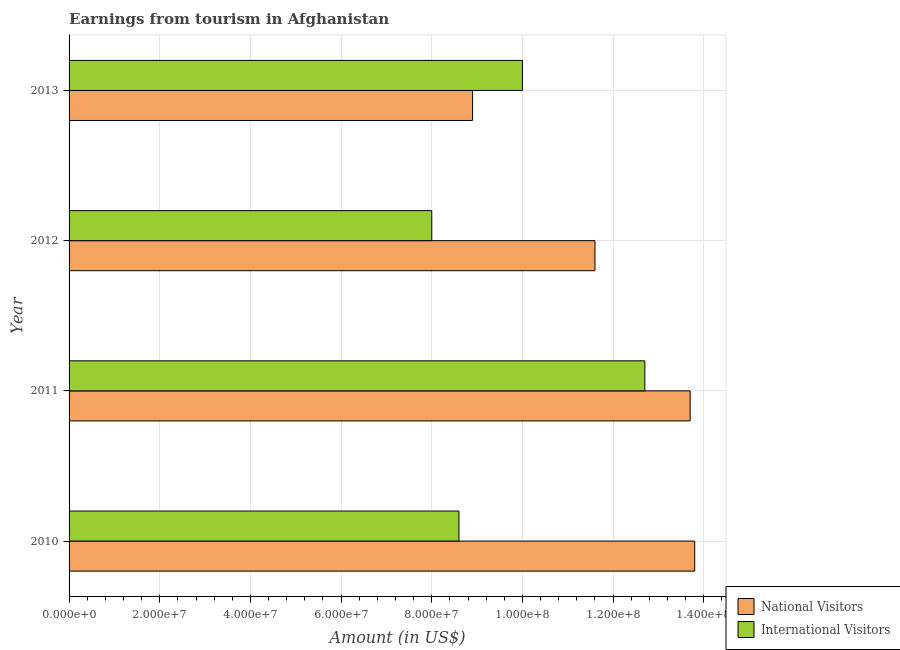How many groups of bars are there?
Your answer should be very brief. 4. Are the number of bars per tick equal to the number of legend labels?
Ensure brevity in your answer.  Yes. How many bars are there on the 1st tick from the bottom?
Provide a short and direct response. 2. What is the label of the 3rd group of bars from the top?
Provide a short and direct response. 2011. In how many cases, is the number of bars for a given year not equal to the number of legend labels?
Offer a terse response. 0. What is the amount earned from national visitors in 2013?
Give a very brief answer. 8.90e+07. Across all years, what is the maximum amount earned from national visitors?
Offer a very short reply. 1.38e+08. Across all years, what is the minimum amount earned from national visitors?
Offer a terse response. 8.90e+07. What is the total amount earned from national visitors in the graph?
Provide a short and direct response. 4.80e+08. What is the difference between the amount earned from national visitors in 2010 and that in 2011?
Make the answer very short. 1.00e+06. What is the difference between the amount earned from national visitors in 2011 and the amount earned from international visitors in 2012?
Offer a very short reply. 5.70e+07. What is the average amount earned from international visitors per year?
Your answer should be compact. 9.82e+07. In the year 2013, what is the difference between the amount earned from international visitors and amount earned from national visitors?
Provide a short and direct response. 1.10e+07. In how many years, is the amount earned from international visitors greater than 104000000 US$?
Provide a succinct answer. 1. What is the ratio of the amount earned from international visitors in 2011 to that in 2013?
Offer a terse response. 1.27. Is the amount earned from national visitors in 2010 less than that in 2012?
Give a very brief answer. No. Is the difference between the amount earned from national visitors in 2011 and 2012 greater than the difference between the amount earned from international visitors in 2011 and 2012?
Your response must be concise. No. What is the difference between the highest and the lowest amount earned from international visitors?
Your answer should be compact. 4.70e+07. In how many years, is the amount earned from national visitors greater than the average amount earned from national visitors taken over all years?
Offer a terse response. 2. What does the 2nd bar from the top in 2013 represents?
Provide a succinct answer. National Visitors. What does the 1st bar from the bottom in 2010 represents?
Provide a succinct answer. National Visitors. How many bars are there?
Provide a short and direct response. 8. How many years are there in the graph?
Make the answer very short. 4. Where does the legend appear in the graph?
Offer a very short reply. Bottom right. How are the legend labels stacked?
Your answer should be very brief. Vertical. What is the title of the graph?
Offer a very short reply. Earnings from tourism in Afghanistan. Does "Private credit bureau" appear as one of the legend labels in the graph?
Ensure brevity in your answer.  No. What is the Amount (in US$) of National Visitors in 2010?
Provide a short and direct response. 1.38e+08. What is the Amount (in US$) of International Visitors in 2010?
Your answer should be compact. 8.60e+07. What is the Amount (in US$) of National Visitors in 2011?
Give a very brief answer. 1.37e+08. What is the Amount (in US$) of International Visitors in 2011?
Ensure brevity in your answer.  1.27e+08. What is the Amount (in US$) in National Visitors in 2012?
Offer a terse response. 1.16e+08. What is the Amount (in US$) in International Visitors in 2012?
Make the answer very short. 8.00e+07. What is the Amount (in US$) in National Visitors in 2013?
Provide a short and direct response. 8.90e+07. Across all years, what is the maximum Amount (in US$) of National Visitors?
Offer a terse response. 1.38e+08. Across all years, what is the maximum Amount (in US$) of International Visitors?
Give a very brief answer. 1.27e+08. Across all years, what is the minimum Amount (in US$) of National Visitors?
Provide a succinct answer. 8.90e+07. Across all years, what is the minimum Amount (in US$) in International Visitors?
Provide a succinct answer. 8.00e+07. What is the total Amount (in US$) in National Visitors in the graph?
Make the answer very short. 4.80e+08. What is the total Amount (in US$) in International Visitors in the graph?
Offer a terse response. 3.93e+08. What is the difference between the Amount (in US$) in National Visitors in 2010 and that in 2011?
Provide a succinct answer. 1.00e+06. What is the difference between the Amount (in US$) of International Visitors in 2010 and that in 2011?
Your answer should be compact. -4.10e+07. What is the difference between the Amount (in US$) of National Visitors in 2010 and that in 2012?
Provide a short and direct response. 2.20e+07. What is the difference between the Amount (in US$) of International Visitors in 2010 and that in 2012?
Make the answer very short. 6.00e+06. What is the difference between the Amount (in US$) of National Visitors in 2010 and that in 2013?
Your response must be concise. 4.90e+07. What is the difference between the Amount (in US$) in International Visitors in 2010 and that in 2013?
Give a very brief answer. -1.40e+07. What is the difference between the Amount (in US$) in National Visitors in 2011 and that in 2012?
Provide a succinct answer. 2.10e+07. What is the difference between the Amount (in US$) in International Visitors in 2011 and that in 2012?
Offer a terse response. 4.70e+07. What is the difference between the Amount (in US$) in National Visitors in 2011 and that in 2013?
Offer a terse response. 4.80e+07. What is the difference between the Amount (in US$) of International Visitors in 2011 and that in 2013?
Your answer should be very brief. 2.70e+07. What is the difference between the Amount (in US$) in National Visitors in 2012 and that in 2013?
Keep it short and to the point. 2.70e+07. What is the difference between the Amount (in US$) of International Visitors in 2012 and that in 2013?
Your answer should be compact. -2.00e+07. What is the difference between the Amount (in US$) in National Visitors in 2010 and the Amount (in US$) in International Visitors in 2011?
Keep it short and to the point. 1.10e+07. What is the difference between the Amount (in US$) of National Visitors in 2010 and the Amount (in US$) of International Visitors in 2012?
Provide a succinct answer. 5.80e+07. What is the difference between the Amount (in US$) in National Visitors in 2010 and the Amount (in US$) in International Visitors in 2013?
Provide a succinct answer. 3.80e+07. What is the difference between the Amount (in US$) in National Visitors in 2011 and the Amount (in US$) in International Visitors in 2012?
Provide a short and direct response. 5.70e+07. What is the difference between the Amount (in US$) in National Visitors in 2011 and the Amount (in US$) in International Visitors in 2013?
Ensure brevity in your answer.  3.70e+07. What is the difference between the Amount (in US$) in National Visitors in 2012 and the Amount (in US$) in International Visitors in 2013?
Keep it short and to the point. 1.60e+07. What is the average Amount (in US$) of National Visitors per year?
Your response must be concise. 1.20e+08. What is the average Amount (in US$) in International Visitors per year?
Offer a very short reply. 9.82e+07. In the year 2010, what is the difference between the Amount (in US$) in National Visitors and Amount (in US$) in International Visitors?
Offer a very short reply. 5.20e+07. In the year 2011, what is the difference between the Amount (in US$) of National Visitors and Amount (in US$) of International Visitors?
Your answer should be compact. 1.00e+07. In the year 2012, what is the difference between the Amount (in US$) of National Visitors and Amount (in US$) of International Visitors?
Make the answer very short. 3.60e+07. In the year 2013, what is the difference between the Amount (in US$) of National Visitors and Amount (in US$) of International Visitors?
Keep it short and to the point. -1.10e+07. What is the ratio of the Amount (in US$) in National Visitors in 2010 to that in 2011?
Your answer should be very brief. 1.01. What is the ratio of the Amount (in US$) in International Visitors in 2010 to that in 2011?
Your response must be concise. 0.68. What is the ratio of the Amount (in US$) in National Visitors in 2010 to that in 2012?
Make the answer very short. 1.19. What is the ratio of the Amount (in US$) of International Visitors in 2010 to that in 2012?
Keep it short and to the point. 1.07. What is the ratio of the Amount (in US$) of National Visitors in 2010 to that in 2013?
Provide a short and direct response. 1.55. What is the ratio of the Amount (in US$) of International Visitors in 2010 to that in 2013?
Ensure brevity in your answer.  0.86. What is the ratio of the Amount (in US$) in National Visitors in 2011 to that in 2012?
Offer a very short reply. 1.18. What is the ratio of the Amount (in US$) in International Visitors in 2011 to that in 2012?
Your answer should be compact. 1.59. What is the ratio of the Amount (in US$) in National Visitors in 2011 to that in 2013?
Provide a succinct answer. 1.54. What is the ratio of the Amount (in US$) in International Visitors in 2011 to that in 2013?
Provide a short and direct response. 1.27. What is the ratio of the Amount (in US$) in National Visitors in 2012 to that in 2013?
Your response must be concise. 1.3. What is the difference between the highest and the second highest Amount (in US$) of International Visitors?
Your response must be concise. 2.70e+07. What is the difference between the highest and the lowest Amount (in US$) of National Visitors?
Provide a short and direct response. 4.90e+07. What is the difference between the highest and the lowest Amount (in US$) in International Visitors?
Ensure brevity in your answer.  4.70e+07. 